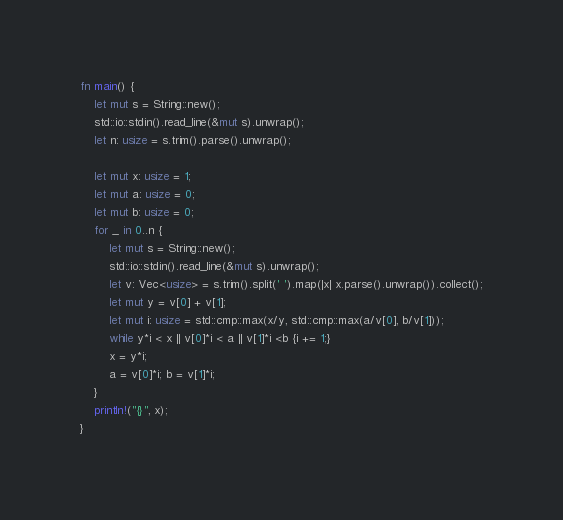<code> <loc_0><loc_0><loc_500><loc_500><_Rust_>fn main() {
    let mut s = String::new();
    std::io::stdin().read_line(&mut s).unwrap();
    let n: usize = s.trim().parse().unwrap();

    let mut x: usize = 1;
    let mut a: usize = 0;
    let mut b: usize = 0;
    for _ in 0..n {
        let mut s = String::new();
        std::io::stdin().read_line(&mut s).unwrap();
        let v: Vec<usize> = s.trim().split(' ').map(|x| x.parse().unwrap()).collect();
        let mut y = v[0] + v[1];
        let mut i: usize = std::cmp::max(x/y, std::cmp::max(a/v[0], b/v[1]));
        while y*i < x || v[0]*i < a || v[1]*i <b {i += 1;}
        x = y*i;
        a = v[0]*i; b = v[1]*i;
    }
    println!("{}", x);
}

</code> 